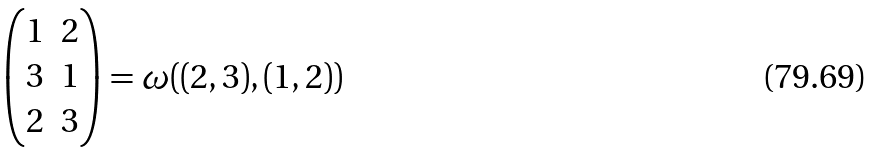Convert formula to latex. <formula><loc_0><loc_0><loc_500><loc_500>\begin{pmatrix} 1 & 2 \\ 3 & 1 \\ 2 & 3 \end{pmatrix} = \omega ( ( 2 , 3 ) , ( 1 , 2 ) )</formula> 